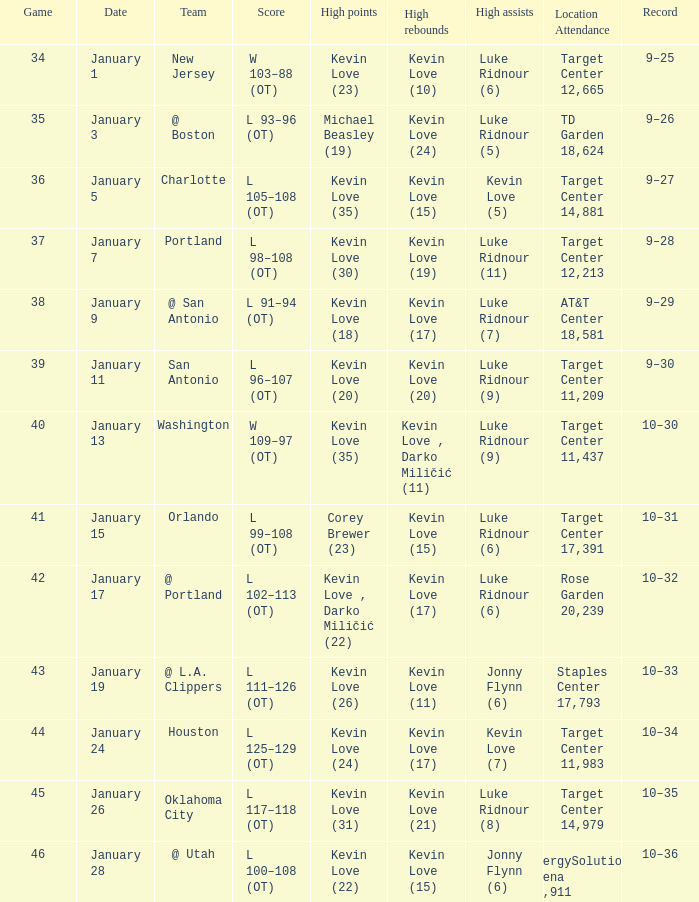How many times did kevin love (22) have the high points? 1.0. 